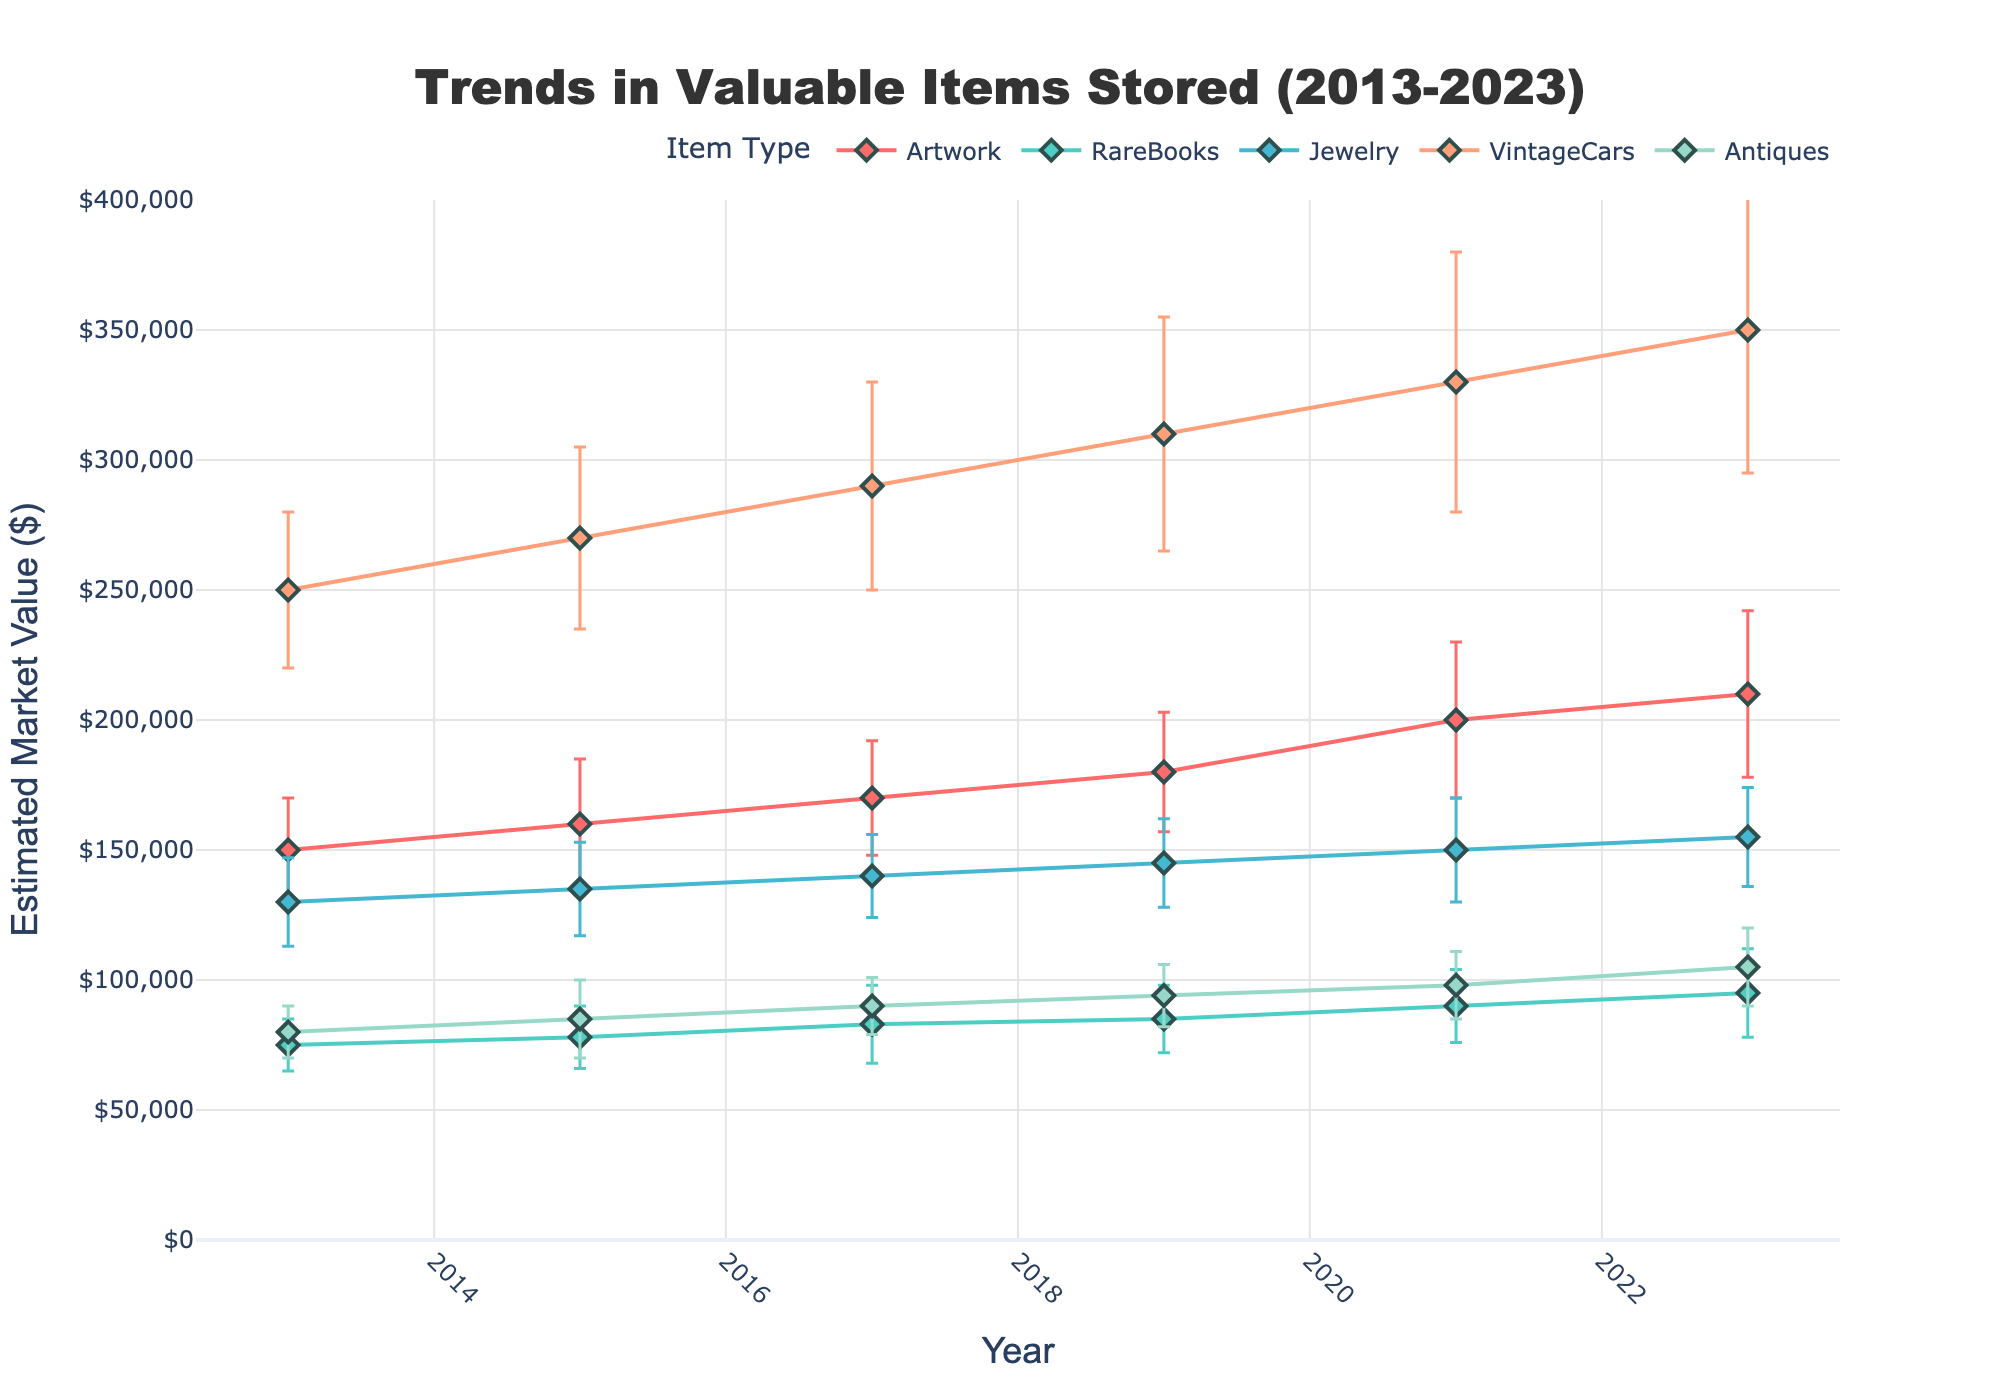What's the title of the figure? The title is typically displayed at the top of the figure. In this case, it's centered and mentions the main topic being analyzed, which is stated as 'Trends in Valuable Items Stored (2013-2023)'.
Answer: Trends in Valuable Items Stored (2013-2023) What are the axes labeled with? The x-axis is usually labeled with a time frame, and in this case, it is 'Year'. The y-axis often represents some form of measurement and here, it is labeled 'Estimated Market Value ($)'.
Answer: Year and Estimated Market Value ($) Which item type had the highest mean value in 2023? To find this, look at the plot at the year 2023. Identify which line (item type) has the highest point on the y-axis for that year. The line for 'VintageCars' is highest in 2023.
Answer: VintageCars What is the trend of mean value for Artwork over the years? Trace the line associated with Artwork from 2013 to 2023. Observe if it generally increases, decreases, or remains stable over the years. The line moves upwards consistently.
Answer: Increases What year had the highest variability (error margin) for Artwork? For each year, find the error bars for Artwork. The longest error bar indicates the highest variability. The error margin for Artwork is the largest in 2021.
Answer: 2021 How did the mean value of RareBooks change from 2013 to 2023? Compare the starting value of RareBooks in 2013 with its value in 2023. The value increases from $75,000 in 2013 to $95,000 in 2023.
Answer: Increased Which item type shows the smallest error margin in 2017? Look at the year 2017 and compare the length of the error bars for each item type. The smallest error margin corresponds to the shortest error bar, which is for Antiques.
Answer: Antiques Between 2019 and 2023, which item type had the greatest increase in mean value? Compare the mean values of each item type in 2019 and 2023 and find the difference. VintageCars had the greatest increase from $310,000 to $350,000, a $40,000 increase.
Answer: VintageCars What was the mean value of Jewelry in 2021 and its error margin? Locate the data point for Jewelry in 2021. The mean value is where the marker is placed, and the error margin is the length of the error bar. The mean value is $150,000 with an error margin of $20,000.
Answer: $150,000 and $20,000 